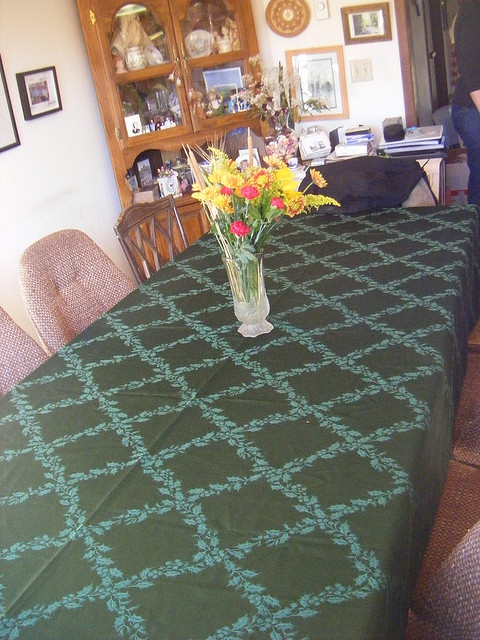Describe the objects in this image and their specific colors. I can see dining table in tan, gray, darkgreen, teal, and darkgray tones, chair in tan, brown, maroon, and black tones, chair in tan, lightpink, darkgray, gray, and lightgray tones, chair in tan, purple, black, and gray tones, and people in tan, purple, navy, and black tones in this image. 